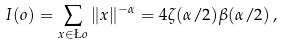<formula> <loc_0><loc_0><loc_500><loc_500>I ( o ) = \sum _ { x \in \L o } \| x \| ^ { - \alpha } = 4 \zeta ( \alpha / 2 ) \beta ( \alpha / 2 ) \, ,</formula> 